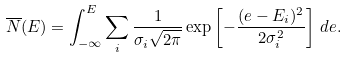<formula> <loc_0><loc_0><loc_500><loc_500>\overline { N } ( E ) = \int _ { - \infty } ^ { E } \sum _ { i } \frac { 1 } { \sigma _ { i } \sqrt { 2 \pi } } \exp \left [ - \frac { ( e - E _ { i } ) ^ { 2 } } { 2 \sigma _ { i } ^ { 2 } } \right ] \, d e .</formula> 